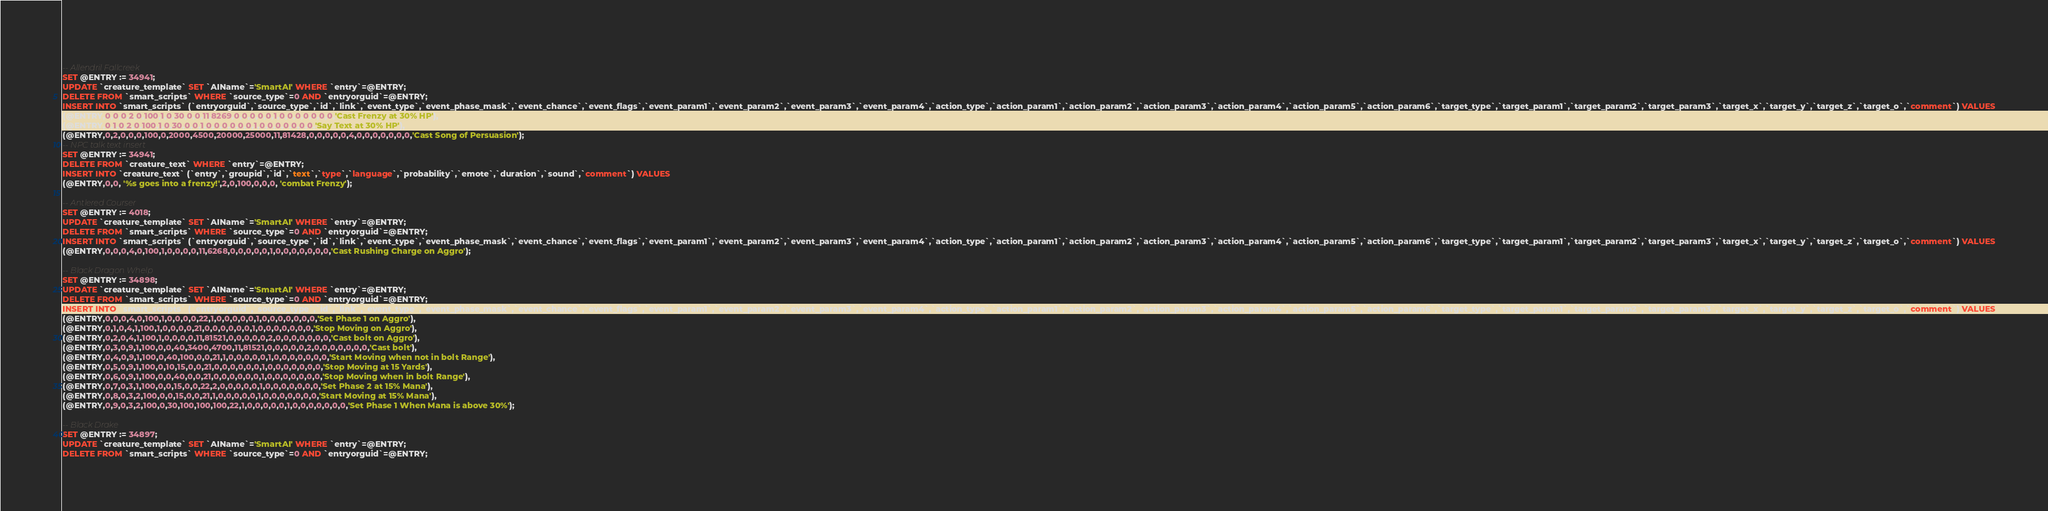<code> <loc_0><loc_0><loc_500><loc_500><_SQL_> 
-- Allendril Fallcreek
SET @ENTRY := 34941;
UPDATE `creature_template` SET `AIName`='SmartAI' WHERE `entry`=@ENTRY;
DELETE FROM `smart_scripts` WHERE `source_type`=0 AND `entryorguid`=@ENTRY;
INSERT INTO `smart_scripts` (`entryorguid`,`source_type`,`id`,`link`,`event_type`,`event_phase_mask`,`event_chance`,`event_flags`,`event_param1`,`event_param2`,`event_param3`,`event_param4`,`action_type`,`action_param1`,`action_param2`,`action_param3`,`action_param4`,`action_param5`,`action_param6`,`target_type`,`target_param1`,`target_param2`,`target_param3`,`target_x`,`target_y`,`target_z`,`target_o`,`comment`) VALUES
(@ENTRY,0,0,0,2,0,100,1,0,30,0,0,11,8269,0,0,0,0,0,1,0,0,0,0,0,0,0,'Cast Frenzy at 30% HP'),
(@ENTRY,0,1,0,2,0,100,1,0,30,0,0,1,0,0,0,0,0,0,1,0,0,0,0,0,0,0,'Say Text at 30% HP'),
(@ENTRY,0,2,0,0,0,100,0,2000,4500,20000,25000,11,81428,0,0,0,0,0,4,0,0,0,0,0,0,0,'Cast Song of Persuasion');
-- NPC talk text insert
SET @ENTRY := 34941;
DELETE FROM `creature_text` WHERE `entry`=@ENTRY;
INSERT INTO `creature_text` (`entry`,`groupid`,`id`,`text`,`type`,`language`,`probability`,`emote`,`duration`,`sound`,`comment`) VALUES
(@ENTRY,0,0, '%s goes into a frenzy!',2,0,100,0,0,0, 'combat Frenzy');

-- Antlered Courser
SET @ENTRY := 4018;
UPDATE `creature_template` SET `AIName`='SmartAI' WHERE `entry`=@ENTRY;
DELETE FROM `smart_scripts` WHERE `source_type`=0 AND `entryorguid`=@ENTRY;
INSERT INTO `smart_scripts` (`entryorguid`,`source_type`,`id`,`link`,`event_type`,`event_phase_mask`,`event_chance`,`event_flags`,`event_param1`,`event_param2`,`event_param3`,`event_param4`,`action_type`,`action_param1`,`action_param2`,`action_param3`,`action_param4`,`action_param5`,`action_param6`,`target_type`,`target_param1`,`target_param2`,`target_param3`,`target_x`,`target_y`,`target_z`,`target_o`,`comment`) VALUES
(@ENTRY,0,0,0,4,0,100,1,0,0,0,0,11,6268,0,0,0,0,0,1,0,0,0,0,0,0,0,'Cast Rushing Charge on Aggro');

-- Black Dragon Whelp
SET @ENTRY := 34898;
UPDATE `creature_template` SET `AIName`='SmartAI' WHERE `entry`=@ENTRY;
DELETE FROM `smart_scripts` WHERE `source_type`=0 AND `entryorguid`=@ENTRY;
INSERT INTO `smart_scripts` (`entryorguid`,`source_type`,`id`,`link`,`event_type`,`event_phase_mask`,`event_chance`,`event_flags`,`event_param1`,`event_param2`,`event_param3`,`event_param4`,`action_type`,`action_param1`,`action_param2`,`action_param3`,`action_param4`,`action_param5`,`action_param6`,`target_type`,`target_param1`,`target_param2`,`target_param3`,`target_x`,`target_y`,`target_z`,`target_o`,`comment`) VALUES
(@ENTRY,0,0,0,4,0,100,1,0,0,0,0,22,1,0,0,0,0,0,1,0,0,0,0,0,0,0,'Set Phase 1 on Aggro'),
(@ENTRY,0,1,0,4,1,100,1,0,0,0,0,21,0,0,0,0,0,0,1,0,0,0,0,0,0,0,'Stop Moving on Aggro'),
(@ENTRY,0,2,0,4,1,100,1,0,0,0,0,11,81521,0,0,0,0,0,2,0,0,0,0,0,0,0,'Cast bolt on Aggro'),
(@ENTRY,0,3,0,9,1,100,0,0,40,3400,4700,11,81521,0,0,0,0,0,2,0,0,0,0,0,0,0,'Cast bolt'),
(@ENTRY,0,4,0,9,1,100,0,40,100,0,0,21,1,0,0,0,0,0,1,0,0,0,0,0,0,0,'Start Moving when not in bolt Range'),
(@ENTRY,0,5,0,9,1,100,0,10,15,0,0,21,0,0,0,0,0,0,1,0,0,0,0,0,0,0,'Stop Moving at 15 Yards'),
(@ENTRY,0,6,0,9,1,100,0,0,40,0,0,21,0,0,0,0,0,0,1,0,0,0,0,0,0,0,'Stop Moving when in bolt Range'),
(@ENTRY,0,7,0,3,1,100,0,0,15,0,0,22,2,0,0,0,0,0,1,0,0,0,0,0,0,0,'Set Phase 2 at 15% Mana'),
(@ENTRY,0,8,0,3,2,100,0,0,15,0,0,21,1,0,0,0,0,0,1,0,0,0,0,0,0,0,'Start Moving at 15% Mana'),
(@ENTRY,0,9,0,3,2,100,0,30,100,100,100,22,1,0,0,0,0,0,1,0,0,0,0,0,0,0,'Set Phase 1 When Mana is above 30%');

-- Black Drake
SET @ENTRY := 34897;
UPDATE `creature_template` SET `AIName`='SmartAI' WHERE `entry`=@ENTRY;
DELETE FROM `smart_scripts` WHERE `source_type`=0 AND `entryorguid`=@ENTRY;</code> 